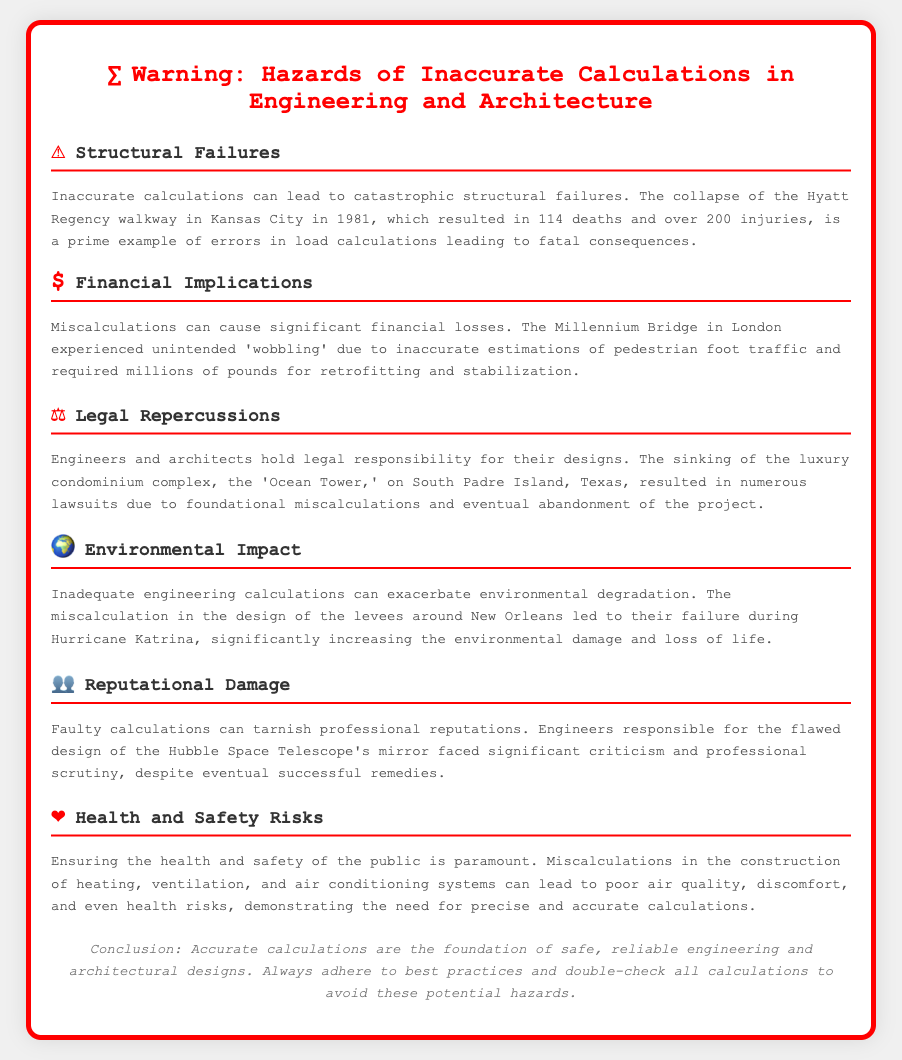What event exemplifies structural failures from inaccurate calculations? The document mentions the collapse of the Hyatt Regency walkway in Kansas City as an example of structural failure due to load calculation errors.
Answer: Hyatt Regency walkway What year did the Hyatt Regency walkway collapse? The document states that the Hyatt Regency walkway collapse occurred in 1981.
Answer: 1981 What was the financial effect of the Millennium Bridge miscalculations? The document notes that the Millennium Bridge required millions of pounds for retrofitting and stabilization due to miscalculations.
Answer: millions of pounds What is a consequence of the sinking of the Ocean Tower? The document indicates that the sinking of the Ocean Tower led to numerous lawsuits due to foundational miscalculations.
Answer: numerous lawsuits What disaster was exacerbated by inadequate engineering calculations? The document mentions that miscalculations in levee design led to failures during Hurricane Katrina.
Answer: Hurricane Katrina What type of damage can result from faulty calculations according to the document? The document describes reputational damage as a consequence of faulty calculations.
Answer: Reputational damage What health risk is associated with miscalculations in HVAC systems? The document explains that poor air quality can result from miscalculations in HVAC system construction.
Answer: Poor air quality What is emphasized as crucial for engineering and architectural designs? The document stresses that accurate calculations are vital for safe and reliable designs.
Answer: Accurate calculations 